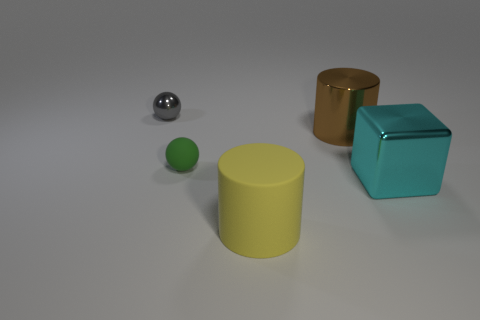Is the number of small gray metal spheres that are behind the big rubber object greater than the number of small red metal cubes?
Your answer should be compact. Yes. Are any gray blocks visible?
Offer a very short reply. No. How many other objects are there of the same shape as the big cyan metallic object?
Ensure brevity in your answer.  0. There is a thing to the right of the brown object that is in front of the tiny ball behind the brown object; what is its size?
Your answer should be compact. Large. There is a metallic object that is behind the small green rubber ball and in front of the small shiny ball; what is its shape?
Your answer should be very brief. Cylinder. Are there the same number of cubes behind the green rubber ball and large brown cylinders to the left of the big cyan shiny cube?
Provide a short and direct response. No. Is there a large brown thing that has the same material as the yellow cylinder?
Provide a succinct answer. No. Are the big brown cylinder behind the cyan metallic object and the small gray thing made of the same material?
Make the answer very short. Yes. There is a metal thing that is both right of the metallic ball and behind the large cyan object; what size is it?
Provide a short and direct response. Large. What is the color of the large matte object?
Offer a very short reply. Yellow. 